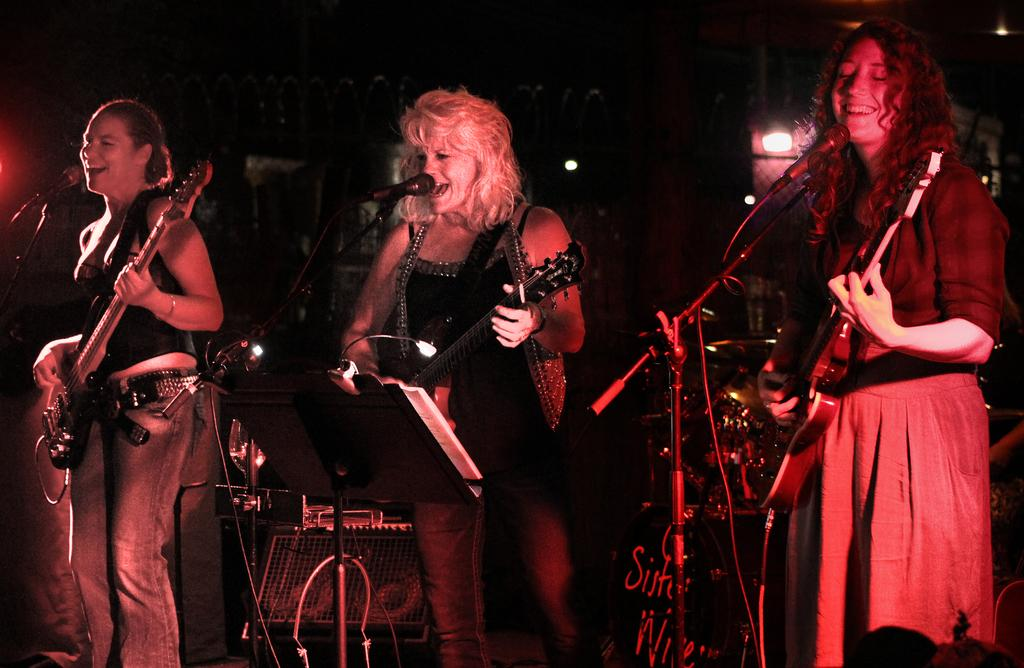How many women are in the image? There are three women in the image. What are the women holding in the image? Each woman is holding a guitar. What are the women doing with the guitars? The women are playing the guitars. What else are the women doing in the image? The women are singing into microphones. What can be seen in the background of the image? There is lighting in the background of the image. How would you describe the overall appearance of the image? The overall image appears to be dark. What type of cap is the woman on the left wearing in the image? There is no cap visible on any of the women in the image. 